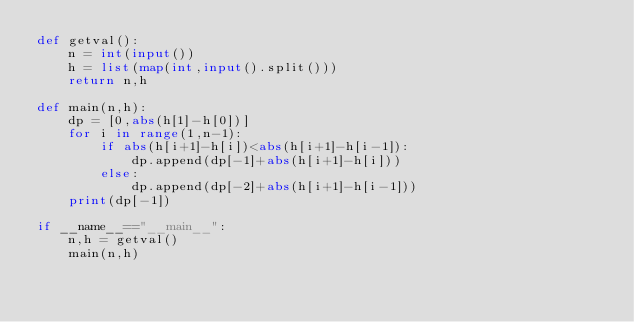Convert code to text. <code><loc_0><loc_0><loc_500><loc_500><_Python_>def getval():
    n = int(input())
    h = list(map(int,input().split()))
    return n,h 

def main(n,h):
    dp = [0,abs(h[1]-h[0])]
    for i in range(1,n-1):
        if abs(h[i+1]-h[i])<abs(h[i+1]-h[i-1]):
            dp.append(dp[-1]+abs(h[i+1]-h[i]))
        else:
            dp.append(dp[-2]+abs(h[i+1]-h[i-1]))
    print(dp[-1])
        
if __name__=="__main__":
    n,h = getval()
    main(n,h)</code> 